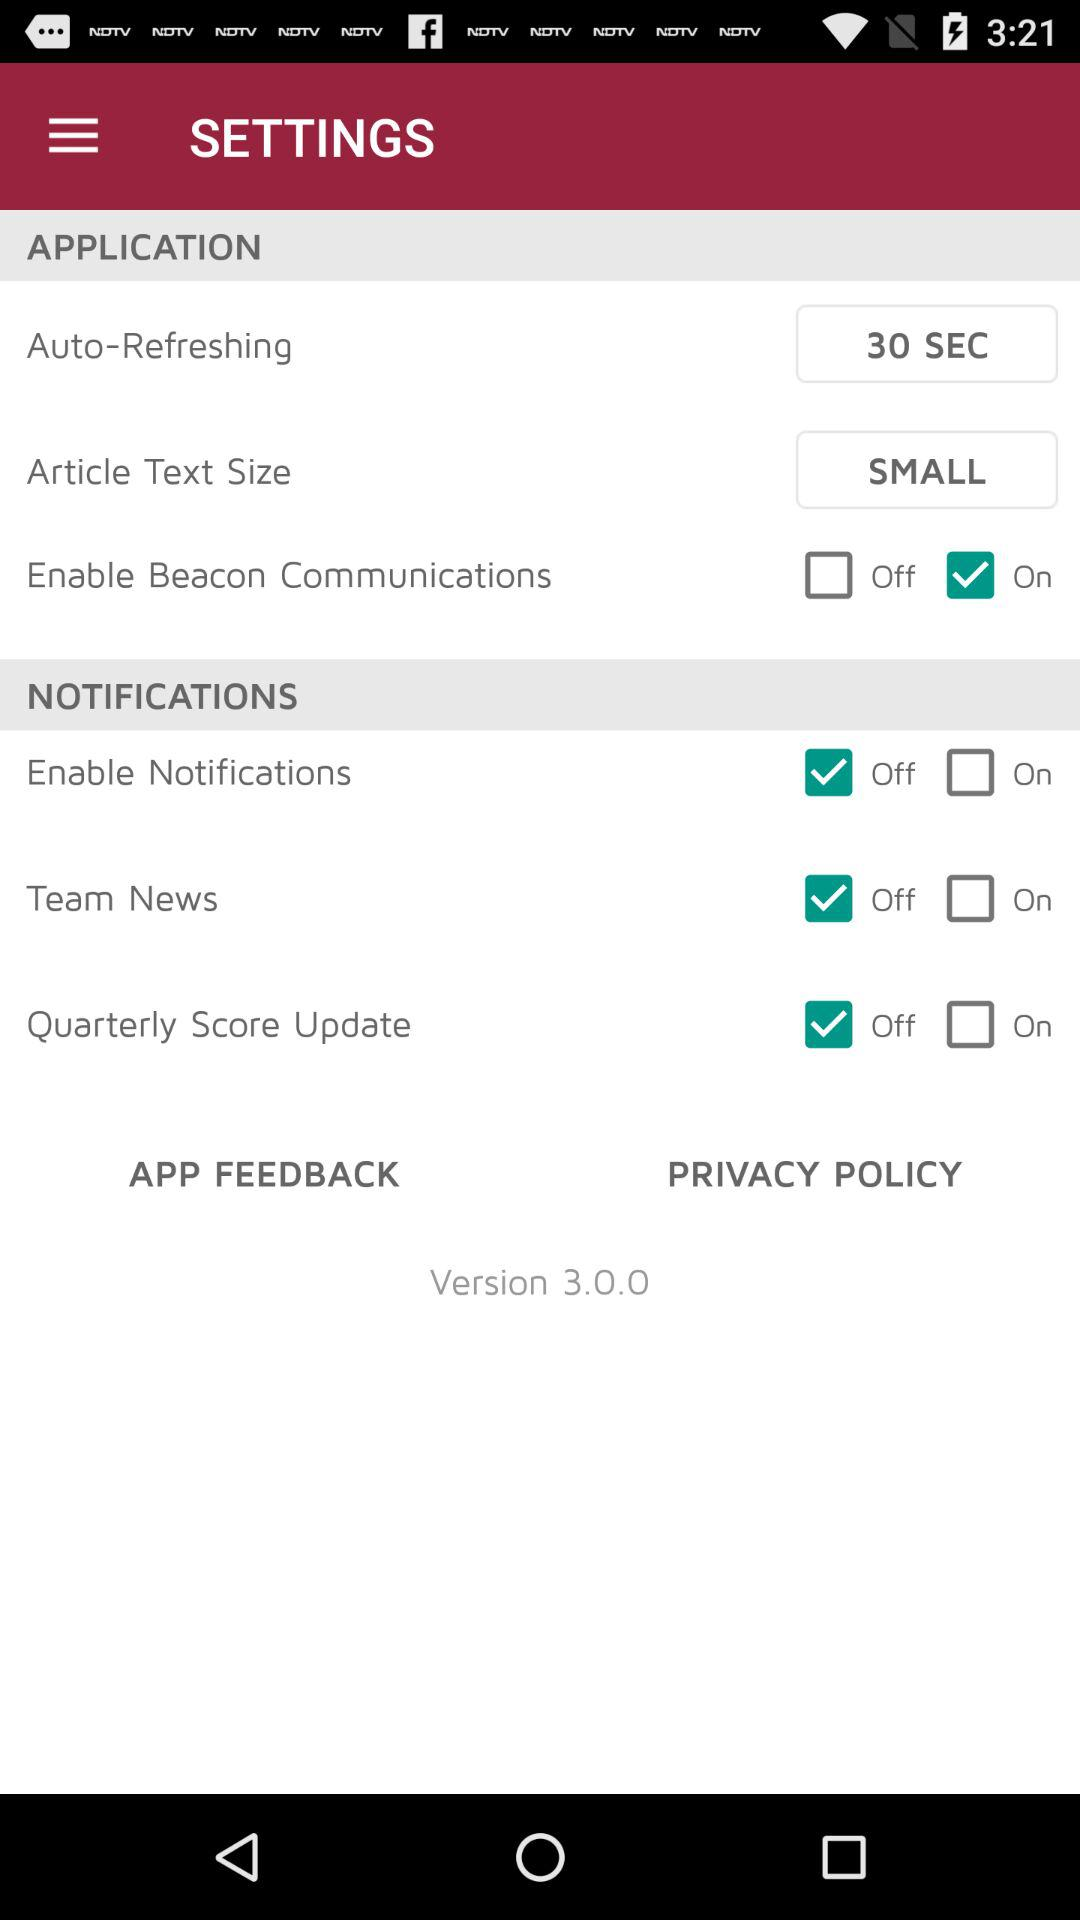What is the given version? The given version is 3.0.0. 